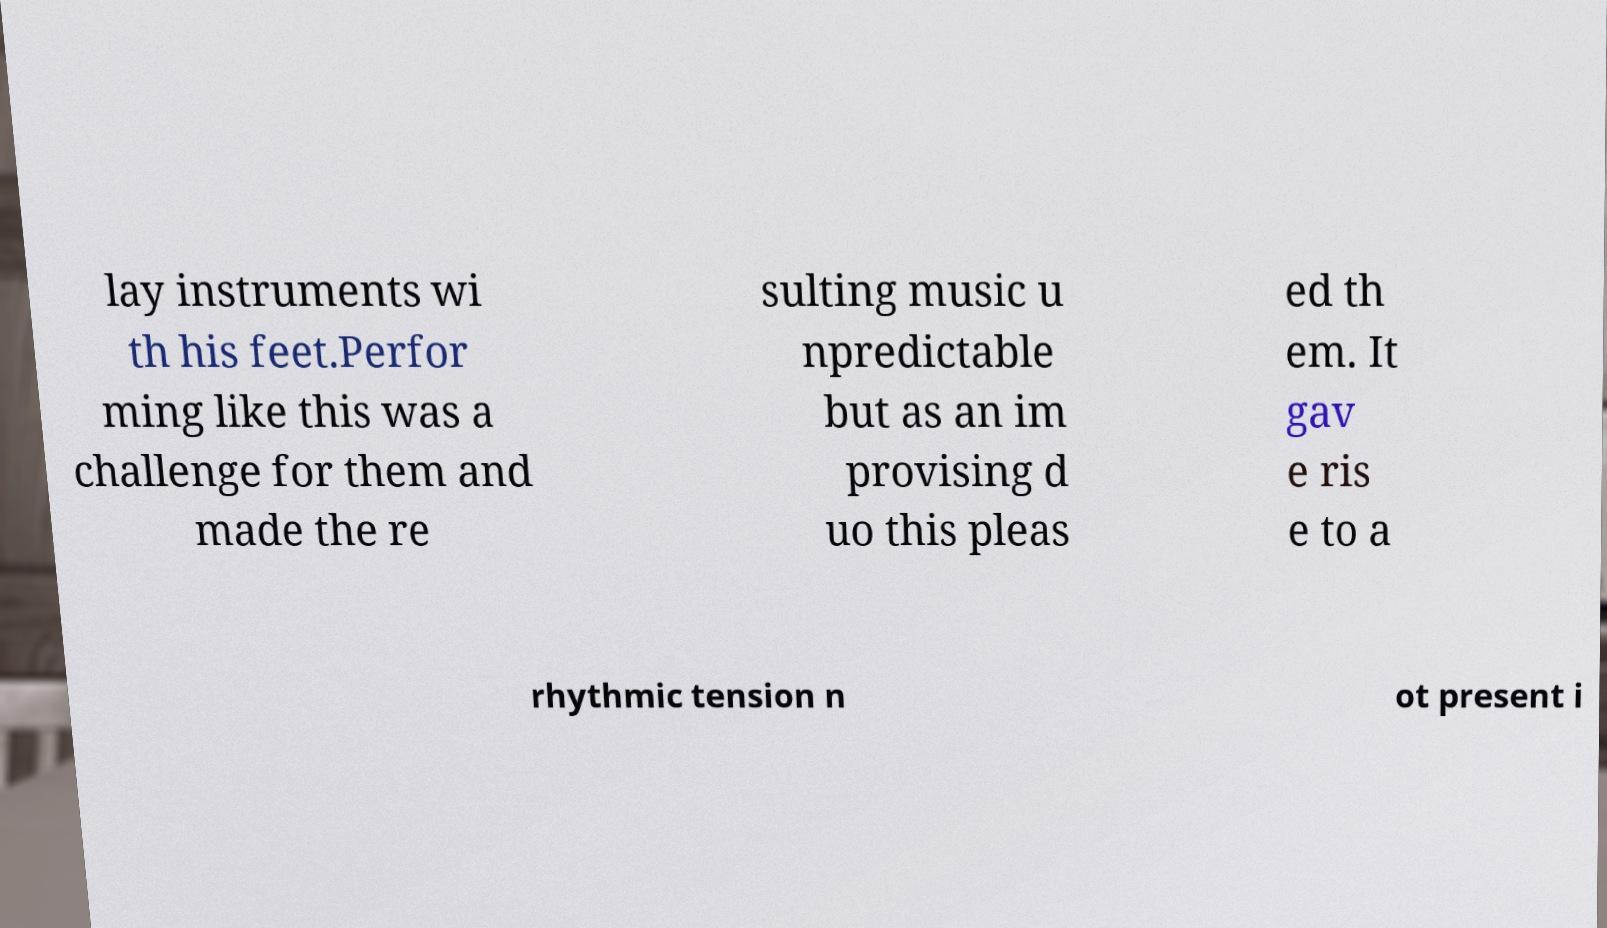Can you accurately transcribe the text from the provided image for me? lay instruments wi th his feet.Perfor ming like this was a challenge for them and made the re sulting music u npredictable but as an im provising d uo this pleas ed th em. It gav e ris e to a rhythmic tension n ot present i 